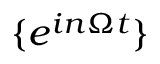<formula> <loc_0><loc_0><loc_500><loc_500>\{ e ^ { i n \Omega t } \}</formula> 